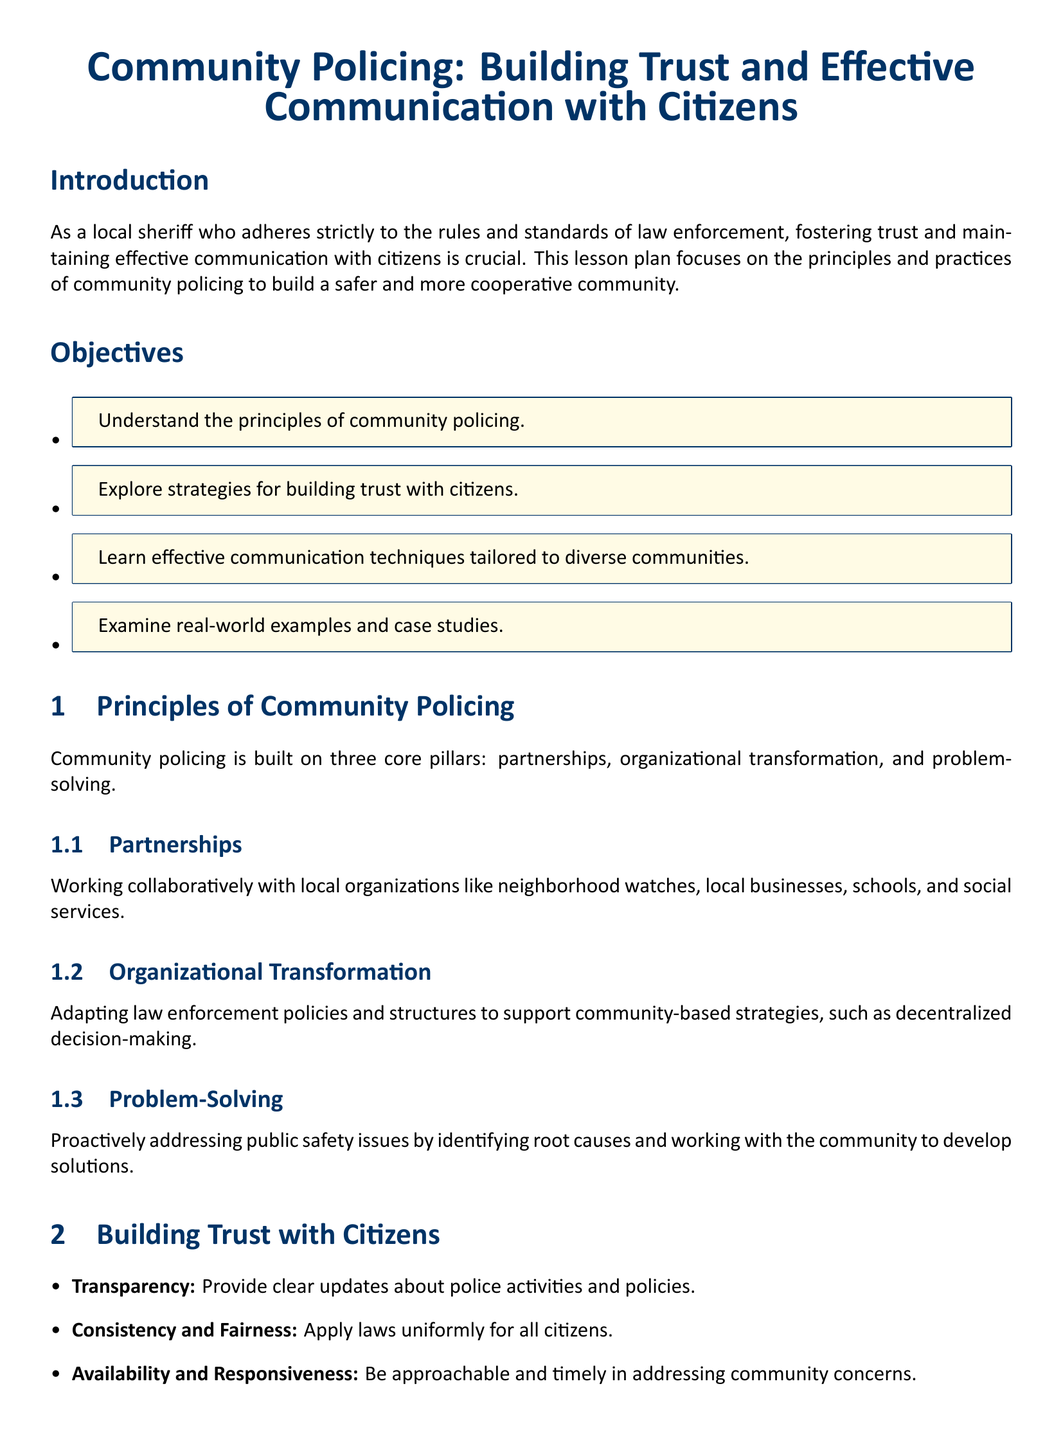What are the three core pillars of community policing? The document outlines three core pillars: partnerships, organizational transformation, and problem-solving.
Answer: partnerships, organizational transformation, problem-solving What is one strategy for building trust with citizens? The document lists strategies such as transparency, consistency and fairness, and availability and responsiveness.
Answer: Transparency What is one effective communication technique mentioned in the lesson plan? The document emphasizes techniques like active listening, cultural sensitivity, and nonverbal communication as effective methods.
Answer: Active Listening Which law enforcement agency implemented the Community Safety Partnership program? The document states that the LAPD implemented the Community Safety Partnership (CSP) program.
Answer: LAPD What type of policing initiative is associated with NYPD? The document identifies the Neighborhood Policing initiative as associated with NYPD.
Answer: Neighborhood Policing What is the purpose of the lesson plan on community policing? The lesson plan aims to foster trust and maintain effective communication with citizens.
Answer: Building trust and effective communication What is the color used for highlighting sections in the document? The document specifies sheriff blue as the color used for titles and important sections.
Answer: sheriff blue What is listed as a resource for understanding community policing? The document includes links to resources such as "Community Policing Defined."
Answer: Community Policing Defined 